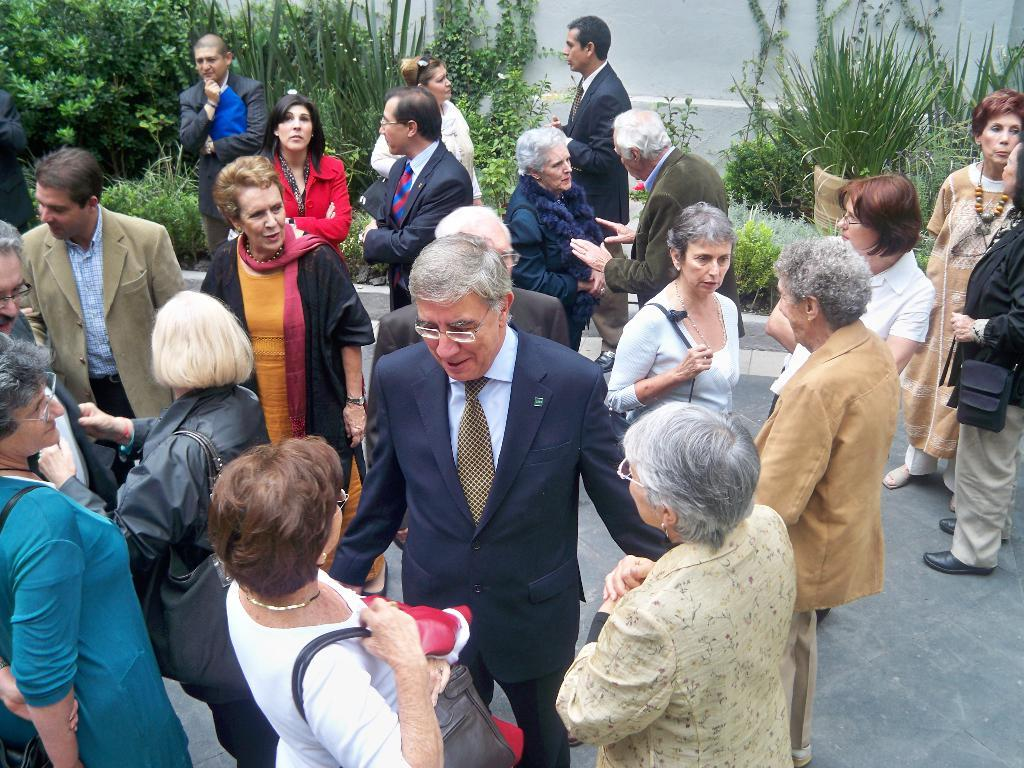What can be seen in the foreground of the picture? There are people standing in the foreground of the picture. What is visible in the background of the picture? There are plants, trees, pots, and other objects in the background of the picture. What is the color of the wall at the top of the image? The wall at the top of the image is painted white. Can you describe the vein structure of the plants in the image? There is no information about the vein structure of the plants in the image, as the focus is on their presence and location. How does the feeling of the people in the foreground of the image compare to the feeling of the plants in the background? There is no information about the feelings of the people or plants in the image, as the focus is on their presence and location. 